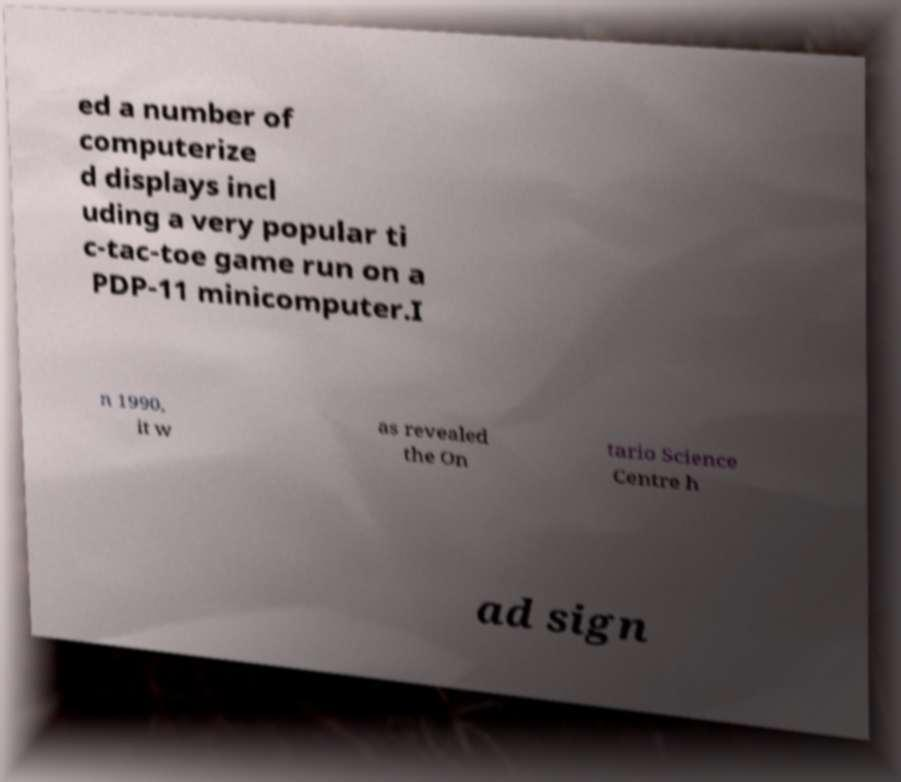I need the written content from this picture converted into text. Can you do that? ed a number of computerize d displays incl uding a very popular ti c-tac-toe game run on a PDP-11 minicomputer.I n 1990, it w as revealed the On tario Science Centre h ad sign 